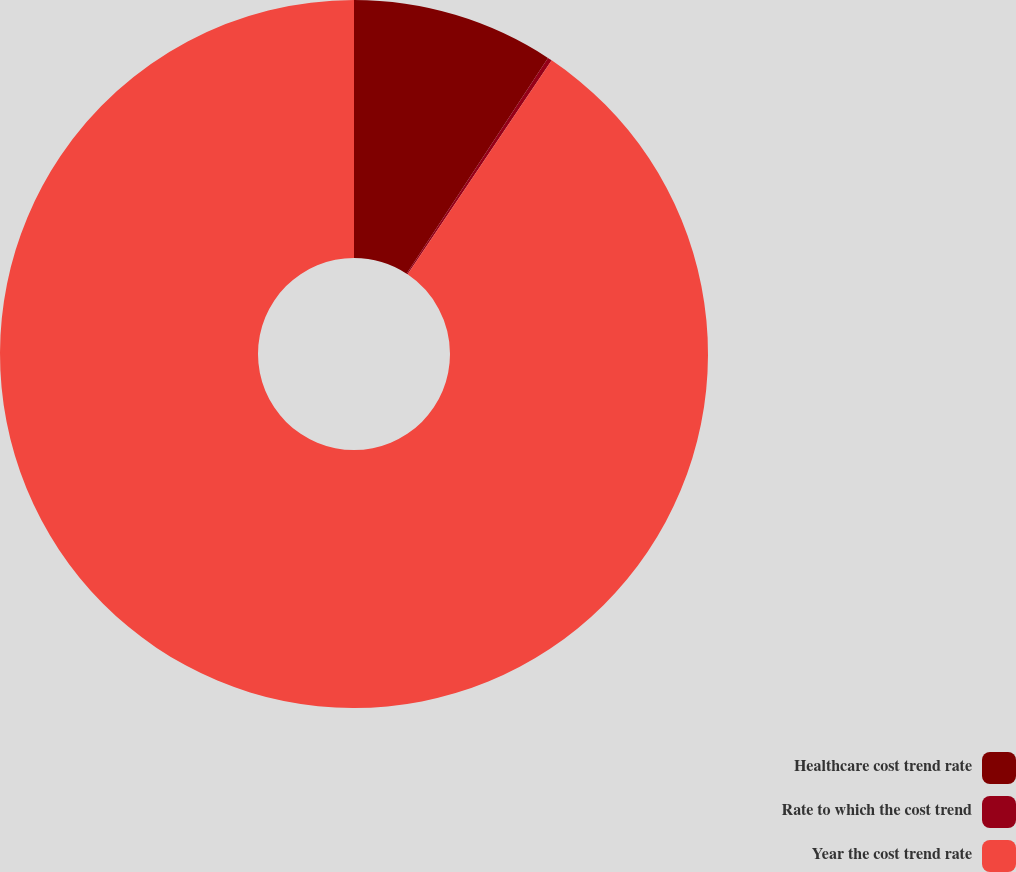Convert chart to OTSL. <chart><loc_0><loc_0><loc_500><loc_500><pie_chart><fcel>Healthcare cost trend rate<fcel>Rate to which the cost trend<fcel>Year the cost trend rate<nl><fcel>9.23%<fcel>0.2%<fcel>90.57%<nl></chart> 